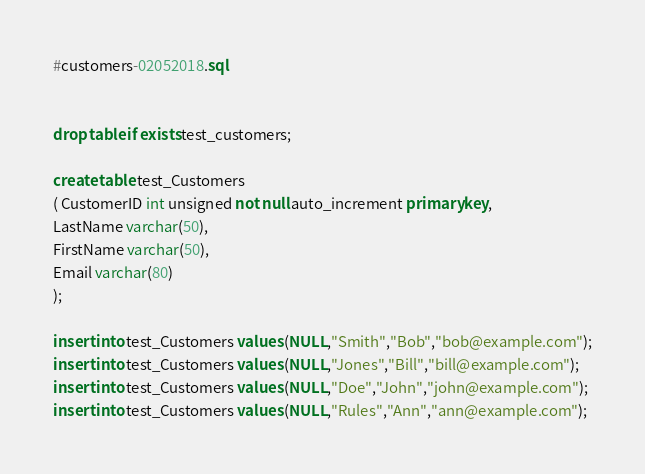Convert code to text. <code><loc_0><loc_0><loc_500><loc_500><_SQL_>#customers-02052018.sql


drop table if exists test_customers;

create table test_Customers
( CustomerID int unsigned not null auto_increment primary key,
LastName varchar(50),
FirstName varchar(50),
Email varchar(80)
);

insert into test_Customers values (NULL,"Smith","Bob","bob@example.com");
insert into test_Customers values (NULL,"Jones","Bill","bill@example.com");
insert into test_Customers values (NULL,"Doe","John","john@example.com");
insert into test_Customers values (NULL,"Rules","Ann","ann@example.com");</code> 